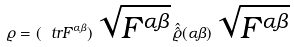<formula> <loc_0><loc_0><loc_500><loc_500>\varrho = ( \ t r F ^ { \alpha \beta } ) \, \sqrt { F ^ { \alpha \beta } } \, \hat { \hat { \varrho } } ( \alpha \beta ) \, \sqrt { F ^ { \alpha \beta } }</formula> 